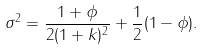Convert formula to latex. <formula><loc_0><loc_0><loc_500><loc_500>\sigma ^ { 2 } = \frac { 1 + \phi } { 2 ( 1 + k ) ^ { 2 } } + \frac { 1 } { 2 } ( 1 - \phi ) .</formula> 